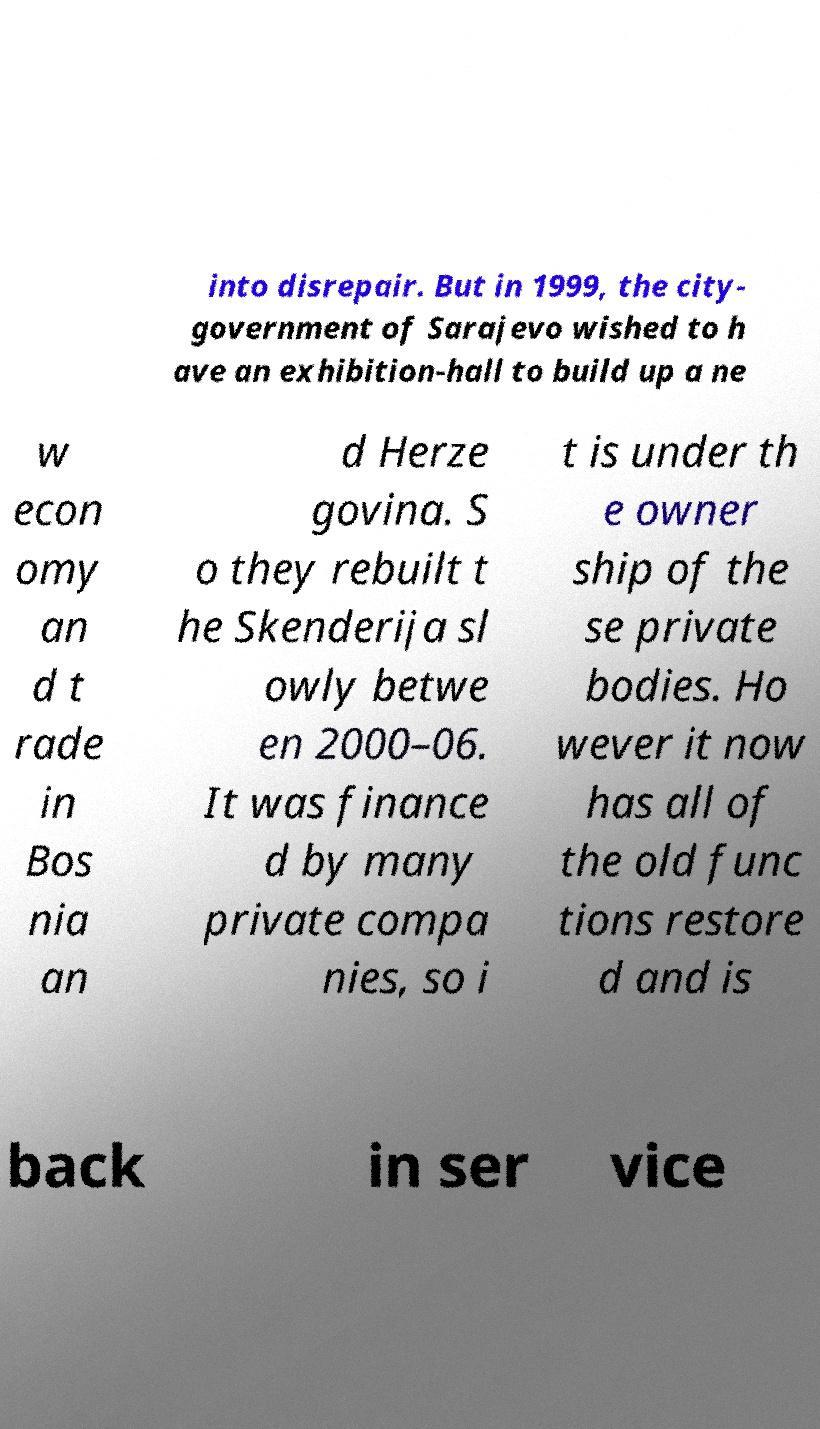I need the written content from this picture converted into text. Can you do that? into disrepair. But in 1999, the city- government of Sarajevo wished to h ave an exhibition-hall to build up a ne w econ omy an d t rade in Bos nia an d Herze govina. S o they rebuilt t he Skenderija sl owly betwe en 2000–06. It was finance d by many private compa nies, so i t is under th e owner ship of the se private bodies. Ho wever it now has all of the old func tions restore d and is back in ser vice 